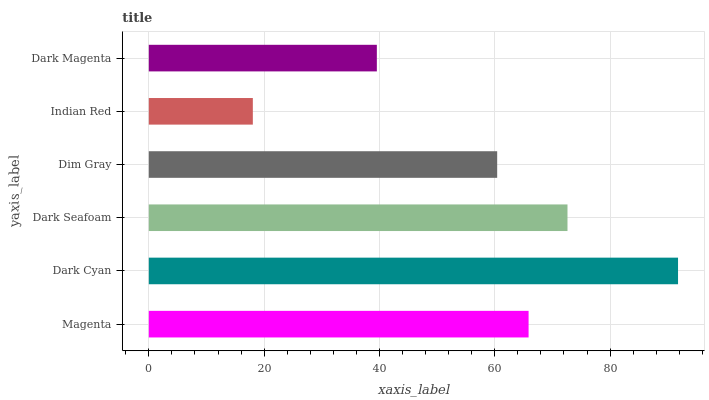Is Indian Red the minimum?
Answer yes or no. Yes. Is Dark Cyan the maximum?
Answer yes or no. Yes. Is Dark Seafoam the minimum?
Answer yes or no. No. Is Dark Seafoam the maximum?
Answer yes or no. No. Is Dark Cyan greater than Dark Seafoam?
Answer yes or no. Yes. Is Dark Seafoam less than Dark Cyan?
Answer yes or no. Yes. Is Dark Seafoam greater than Dark Cyan?
Answer yes or no. No. Is Dark Cyan less than Dark Seafoam?
Answer yes or no. No. Is Magenta the high median?
Answer yes or no. Yes. Is Dim Gray the low median?
Answer yes or no. Yes. Is Indian Red the high median?
Answer yes or no. No. Is Dark Magenta the low median?
Answer yes or no. No. 